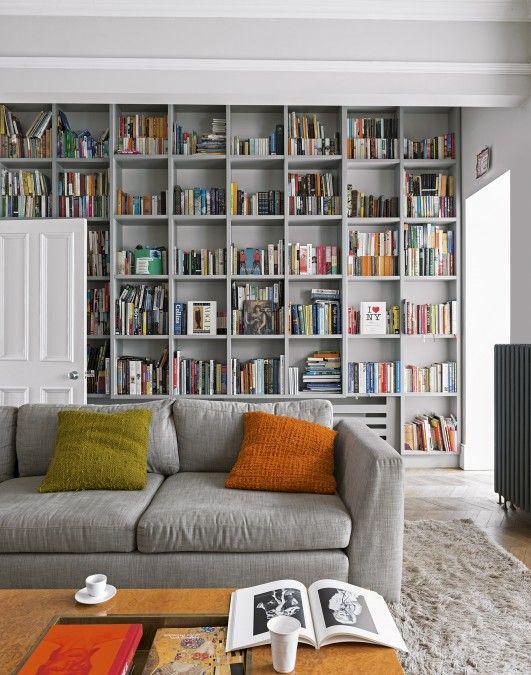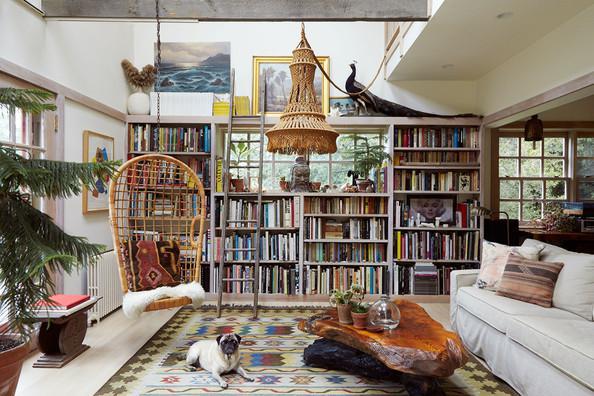The first image is the image on the left, the second image is the image on the right. Analyze the images presented: Is the assertion "A bookshelf sits behind a dark colored couch in the image on the right." valid? Answer yes or no. No. The first image is the image on the left, the second image is the image on the right. For the images shown, is this caption "The white bookshelves in one image are floor to ceiling, while those in the second image stop short of the ceiling and have decorative items displayed on top." true? Answer yes or no. Yes. 